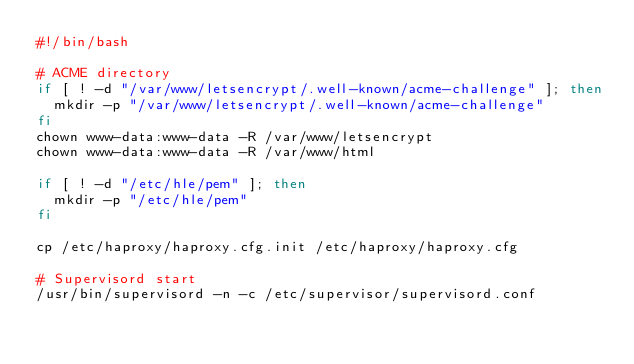Convert code to text. <code><loc_0><loc_0><loc_500><loc_500><_Bash_>#!/bin/bash

# ACME directory
if [ ! -d "/var/www/letsencrypt/.well-known/acme-challenge" ]; then
  mkdir -p "/var/www/letsencrypt/.well-known/acme-challenge"
fi
chown www-data:www-data -R /var/www/letsencrypt
chown www-data:www-data -R /var/www/html

if [ ! -d "/etc/hle/pem" ]; then
  mkdir -p "/etc/hle/pem"
fi

cp /etc/haproxy/haproxy.cfg.init /etc/haproxy/haproxy.cfg

# Supervisord start
/usr/bin/supervisord -n -c /etc/supervisor/supervisord.conf
</code> 